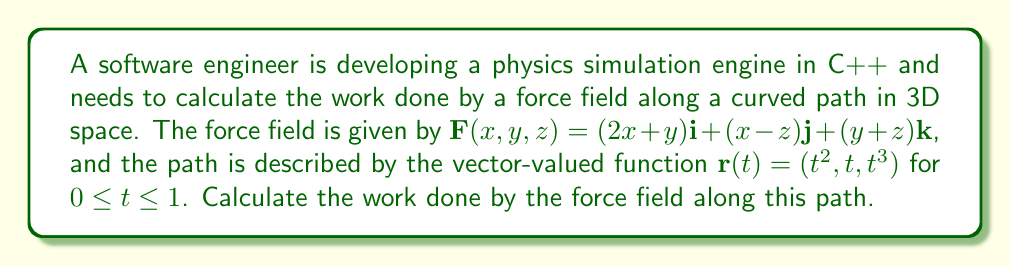Could you help me with this problem? To calculate the work done by a force field along a curved path, we need to use the line integral formula:

$$W = \int_C \mathbf{F} \cdot d\mathbf{r}$$

where $\mathbf{F}$ is the force field and $d\mathbf{r}$ is the differential displacement vector along the path.

Step 1: Express $d\mathbf{r}$ in terms of $t$
$$\mathbf{r}(t) = (t^2, t, t^3)$$
$$\frac{d\mathbf{r}}{dt} = (2t, 1, 3t^2)$$
$$d\mathbf{r} = (2t, 1, 3t^2)dt$$

Step 2: Evaluate $\mathbf{F}(\mathbf{r}(t))$
$$\mathbf{F}(x,y,z) = (2x+y)\mathbf{i} + (x-z)\mathbf{j} + (y+z)\mathbf{k}$$
$$\mathbf{F}(\mathbf{r}(t)) = (2t^2+t)\mathbf{i} + (t^2-t^3)\mathbf{j} + (t+t^3)\mathbf{k}$$

Step 3: Calculate the dot product $\mathbf{F} \cdot d\mathbf{r}$
$$\mathbf{F} \cdot d\mathbf{r} = (2t^2+t)(2t)dt + (t^2-t^3)(1)dt + (t+t^3)(3t^2)dt$$
$$\mathbf{F} \cdot d\mathbf{r} = (4t^3+2t^2+t^2-t^3+3t^3+3t^5)dt$$
$$\mathbf{F} \cdot d\mathbf{r} = (3t^5+6t^3+3t^2)dt$$

Step 4: Integrate from $t=0$ to $t=1$
$$W = \int_0^1 (3t^5+6t^3+3t^2)dt$$
$$W = \left[\frac{1}{2}t^6+\frac{3}{2}t^4+t^3\right]_0^1$$
$$W = \left(\frac{1}{2}+\frac{3}{2}+1\right) - (0+0+0)$$
$$W = 3$$

Therefore, the work done by the force field along the given path is 3 units of work.
Answer: $W = 3$ units of work 